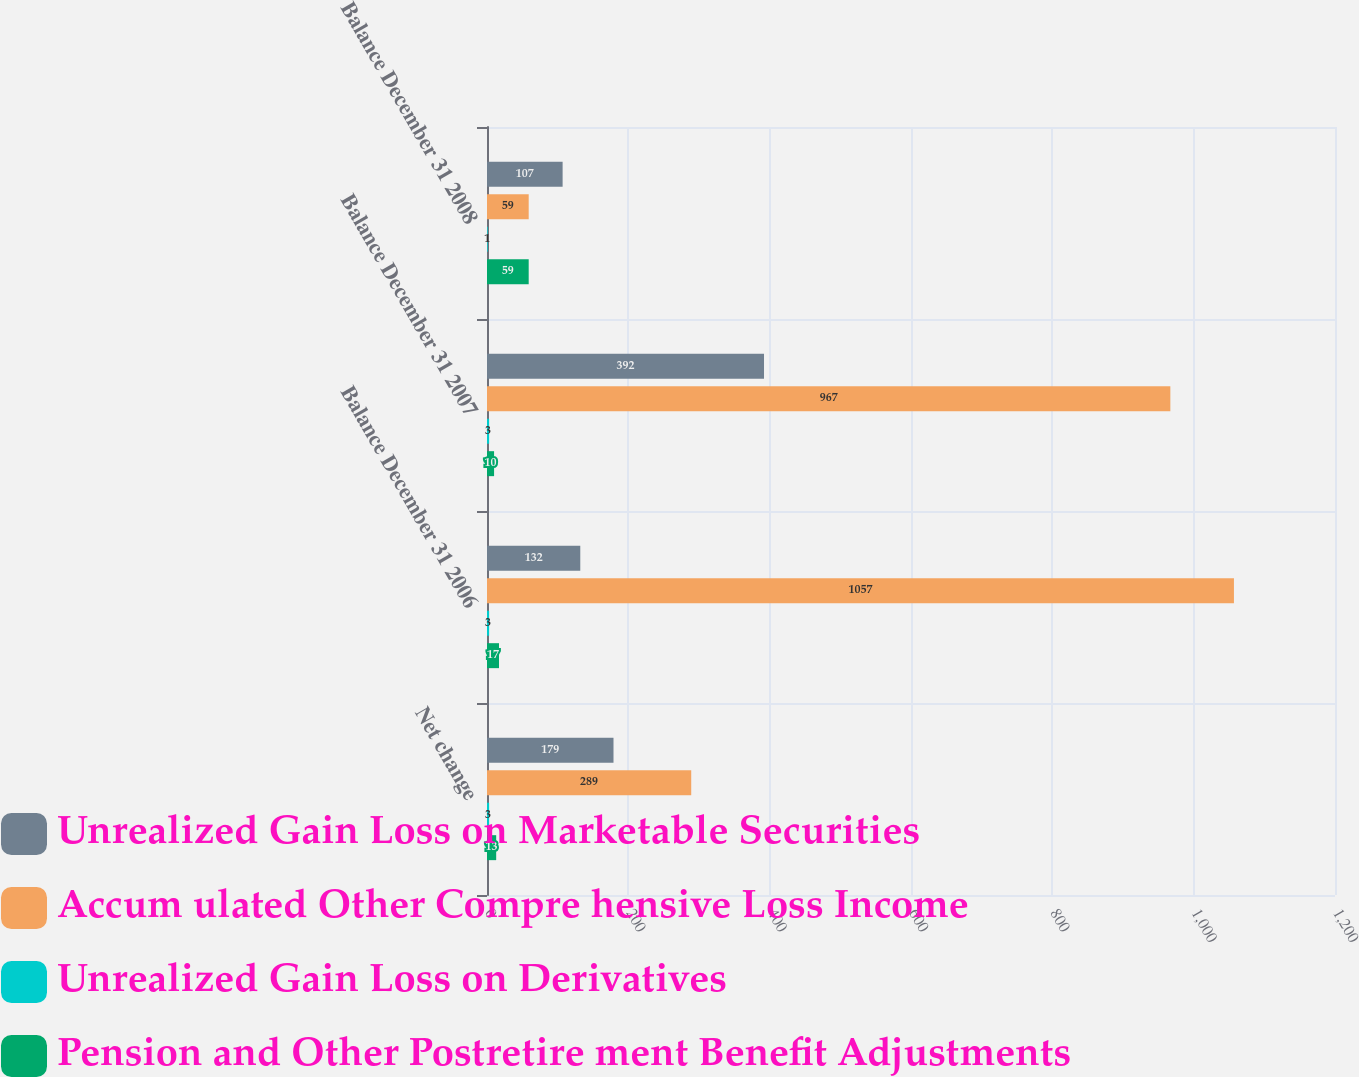Convert chart. <chart><loc_0><loc_0><loc_500><loc_500><stacked_bar_chart><ecel><fcel>Net change<fcel>Balance December 31 2006<fcel>Balance December 31 2007<fcel>Balance December 31 2008<nl><fcel>Unrealized Gain Loss on Marketable Securities<fcel>179<fcel>132<fcel>392<fcel>107<nl><fcel>Accum ulated Other Compre hensive Loss Income<fcel>289<fcel>1057<fcel>967<fcel>59<nl><fcel>Unrealized Gain Loss on Derivatives<fcel>3<fcel>3<fcel>3<fcel>1<nl><fcel>Pension and Other Postretire ment Benefit Adjustments<fcel>13<fcel>17<fcel>10<fcel>59<nl></chart> 